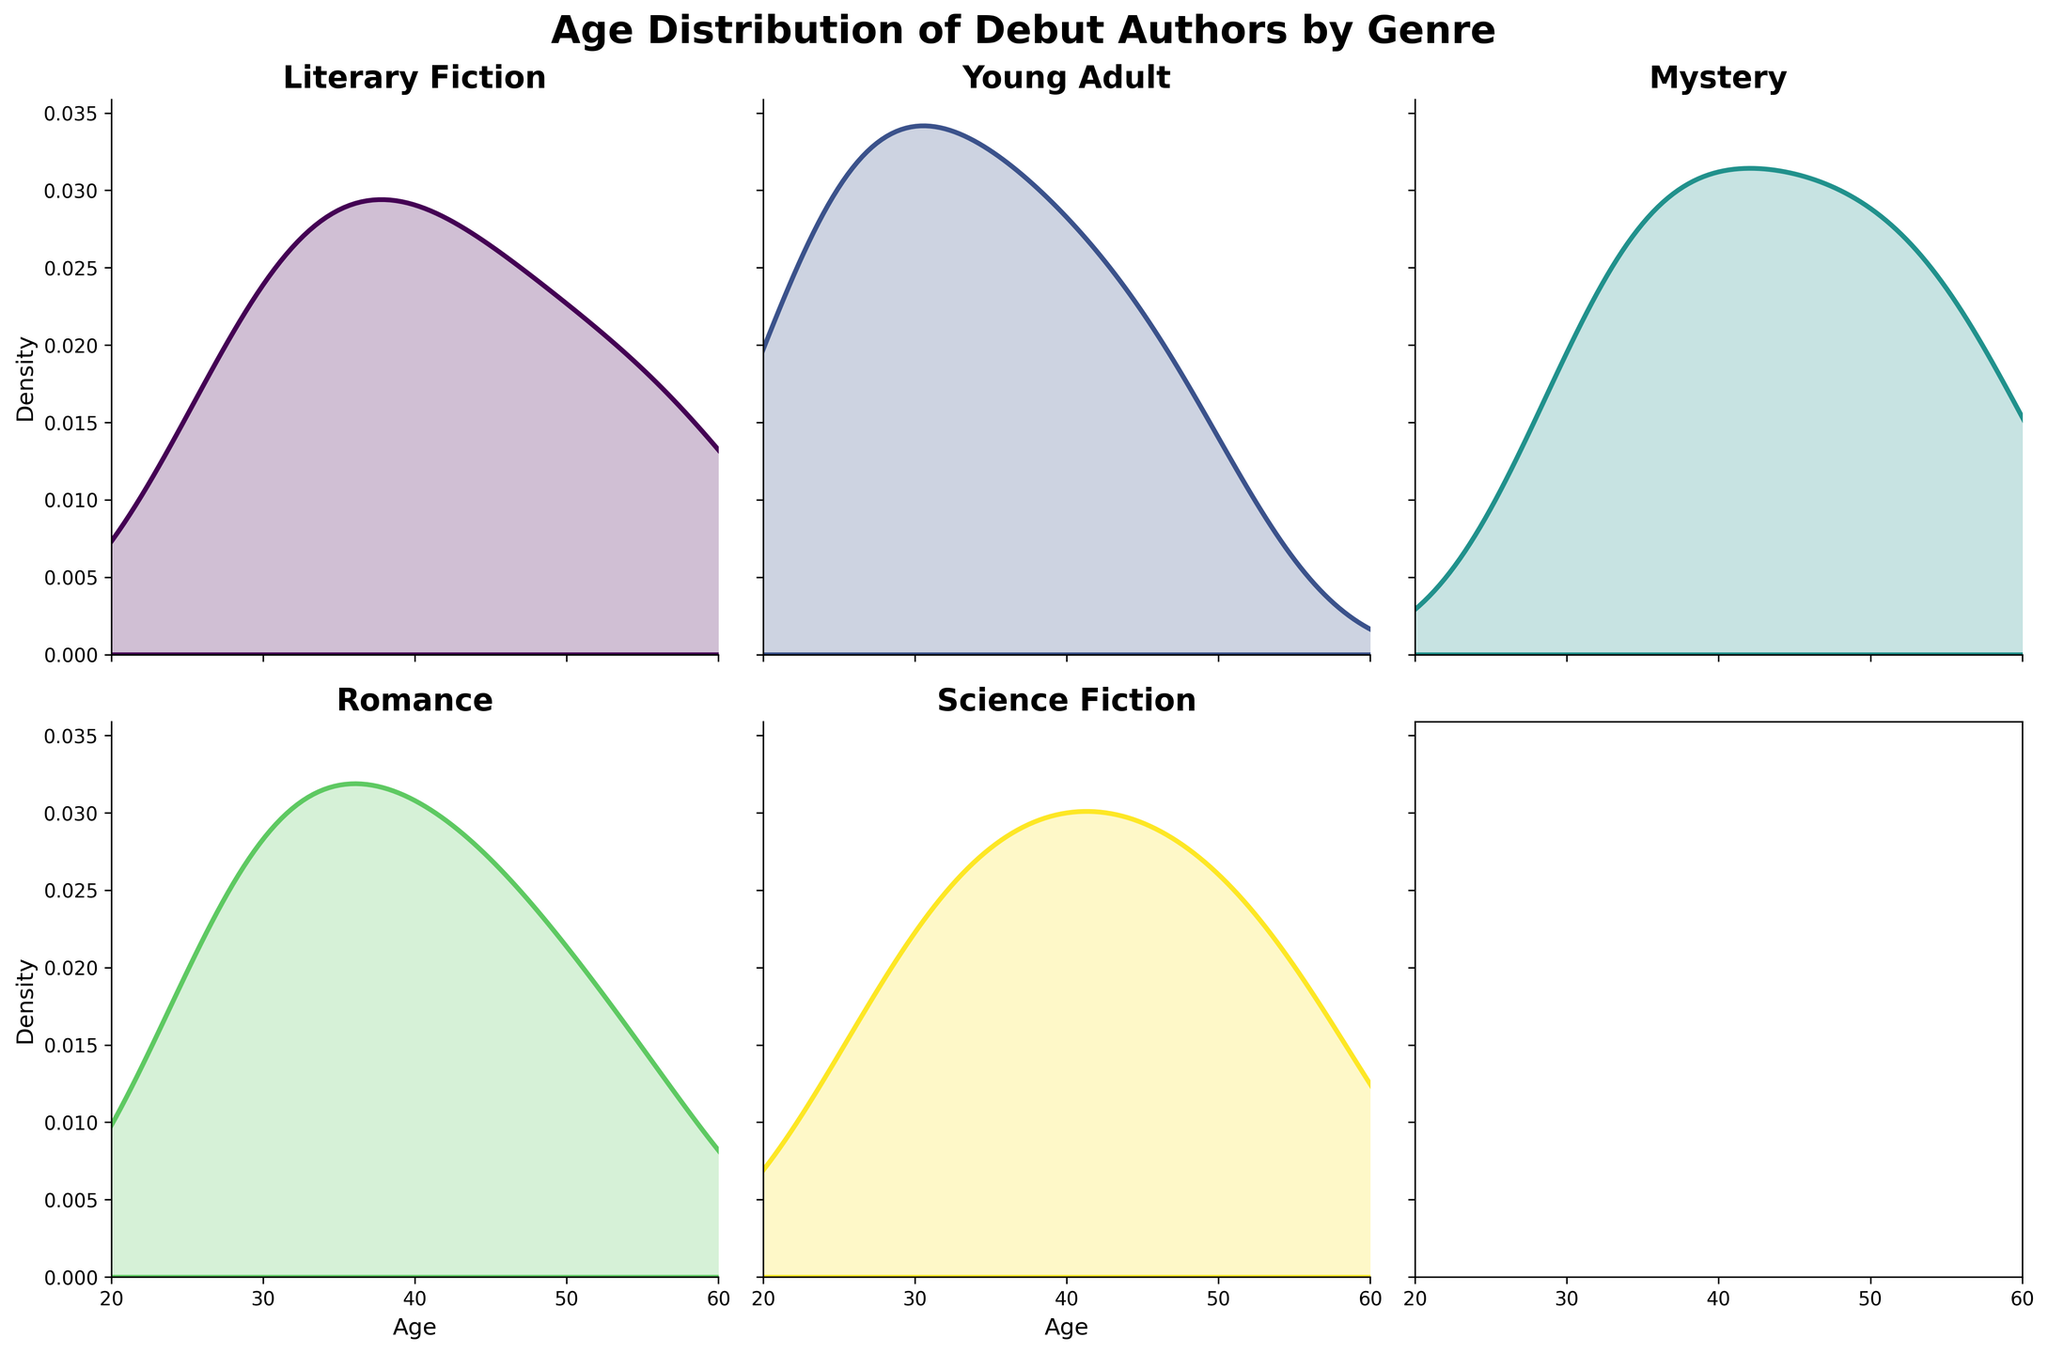What is the title of the figure? The title of the figure is located at the top of the plot and is usually in bold and larger font size.
Answer: Age Distribution of Debut Authors by Genre Which genre has the highest peak in the Young Adult density plot? The highest peak in a density plot indicates the age range with the highest density or frequency of data points. Visually inspect the Young Adult subplot to identify it.
Answer: Around age 25 What is the age range for debut authors in the Literary Fiction genre? The age range can be determined by looking at the lowest and highest values on the x-axis of the Literary Fiction density plot.
Answer: 28 to 59 Which genre shows the widest age distribution? The widest age distribution can be identified by examining which density plot covers the broadest span on the x-axis.
Answer: Literary Fiction Is the density curve for the Mystery genre skewed towards older or younger ages? Analyzing the shape of the curve, if it peaks closer to the higher ages, it is skewed towards older ages; if it peaks closer to the lower ages, it is skewed towards younger ages.
Answer: Older ages Among the genres Romance and Science Fiction, which has a more concentrated density around a single age? Compare the sharpness and height of the peaks in the Romance and Science Fiction plots; sharper and taller peaks indicate more concentration.
Answer: Romance What is the general trend of the debut age in the Science Fiction genre? Assess the overall shape of the density curve to see if most ages are grouped towards the younger end, older end, or uniformly distributed.
Answer: Gradual increase peaking around mid-40s to early 50s Are there any genres where the density plots show multiple peaks (bimodal distribution)? To detect a bimodal distribution, look for density plots that have two distinct peaks.
Answer: No 